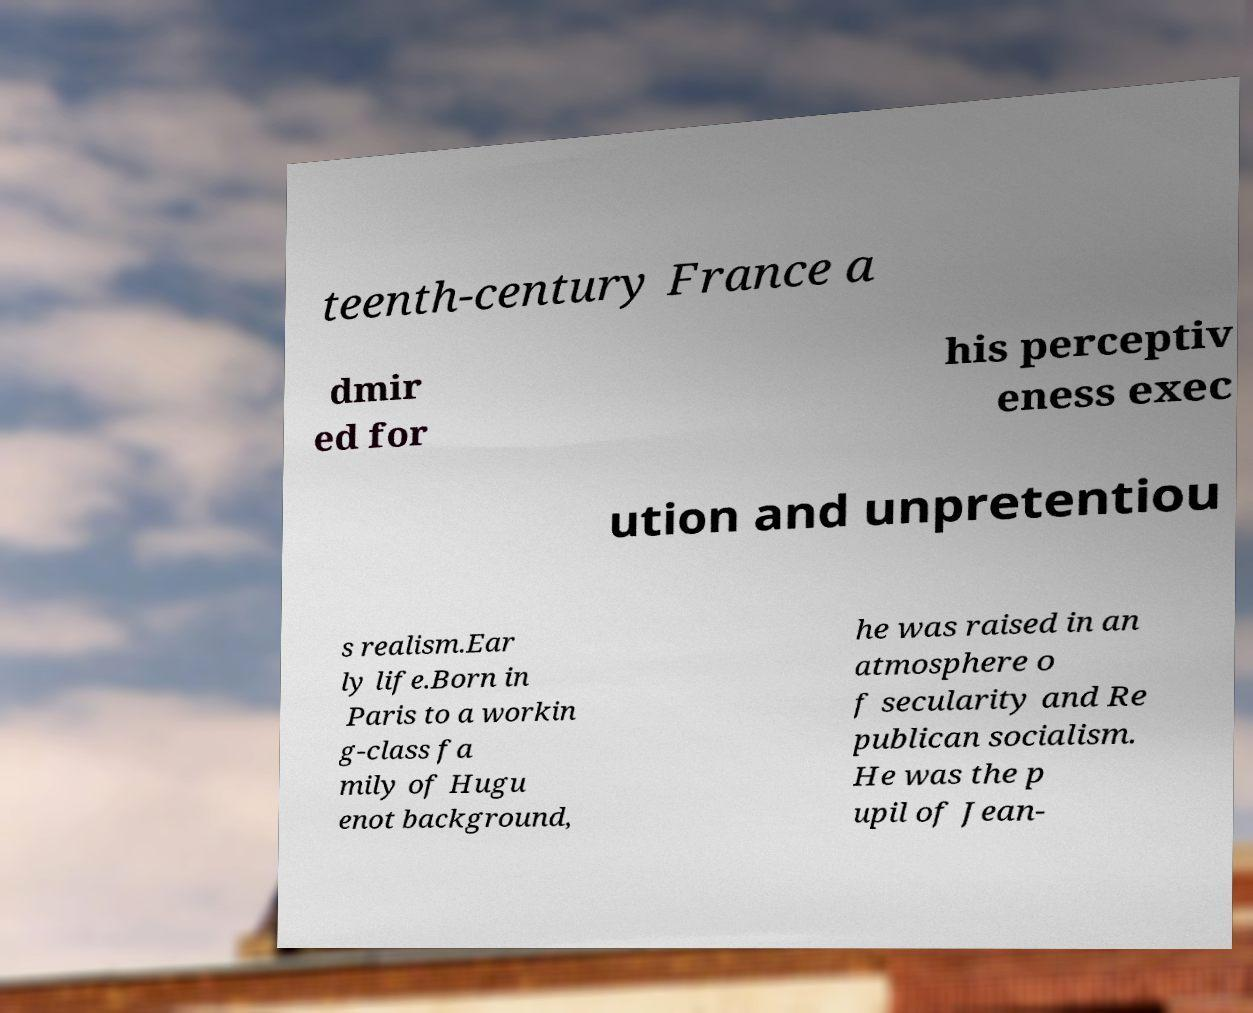Can you accurately transcribe the text from the provided image for me? teenth-century France a dmir ed for his perceptiv eness exec ution and unpretentiou s realism.Ear ly life.Born in Paris to a workin g-class fa mily of Hugu enot background, he was raised in an atmosphere o f secularity and Re publican socialism. He was the p upil of Jean- 